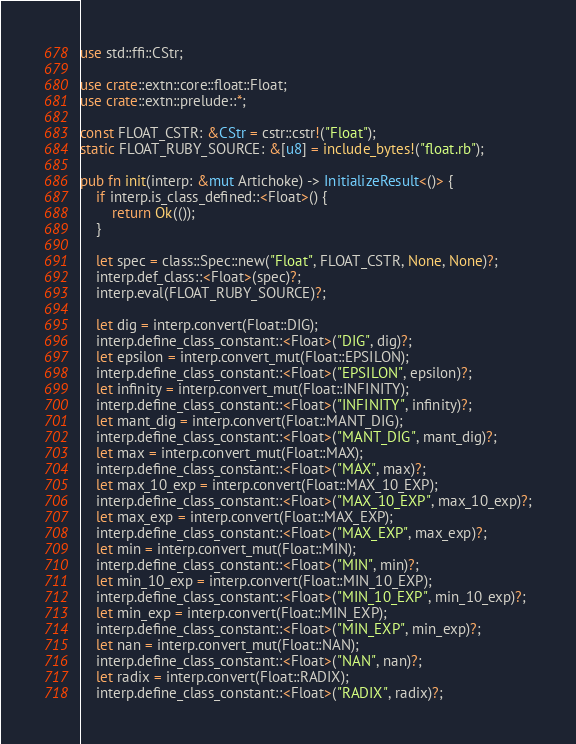<code> <loc_0><loc_0><loc_500><loc_500><_Rust_>use std::ffi::CStr;

use crate::extn::core::float::Float;
use crate::extn::prelude::*;

const FLOAT_CSTR: &CStr = cstr::cstr!("Float");
static FLOAT_RUBY_SOURCE: &[u8] = include_bytes!("float.rb");

pub fn init(interp: &mut Artichoke) -> InitializeResult<()> {
    if interp.is_class_defined::<Float>() {
        return Ok(());
    }

    let spec = class::Spec::new("Float", FLOAT_CSTR, None, None)?;
    interp.def_class::<Float>(spec)?;
    interp.eval(FLOAT_RUBY_SOURCE)?;

    let dig = interp.convert(Float::DIG);
    interp.define_class_constant::<Float>("DIG", dig)?;
    let epsilon = interp.convert_mut(Float::EPSILON);
    interp.define_class_constant::<Float>("EPSILON", epsilon)?;
    let infinity = interp.convert_mut(Float::INFINITY);
    interp.define_class_constant::<Float>("INFINITY", infinity)?;
    let mant_dig = interp.convert(Float::MANT_DIG);
    interp.define_class_constant::<Float>("MANT_DIG", mant_dig)?;
    let max = interp.convert_mut(Float::MAX);
    interp.define_class_constant::<Float>("MAX", max)?;
    let max_10_exp = interp.convert(Float::MAX_10_EXP);
    interp.define_class_constant::<Float>("MAX_10_EXP", max_10_exp)?;
    let max_exp = interp.convert(Float::MAX_EXP);
    interp.define_class_constant::<Float>("MAX_EXP", max_exp)?;
    let min = interp.convert_mut(Float::MIN);
    interp.define_class_constant::<Float>("MIN", min)?;
    let min_10_exp = interp.convert(Float::MIN_10_EXP);
    interp.define_class_constant::<Float>("MIN_10_EXP", min_10_exp)?;
    let min_exp = interp.convert(Float::MIN_EXP);
    interp.define_class_constant::<Float>("MIN_EXP", min_exp)?;
    let nan = interp.convert_mut(Float::NAN);
    interp.define_class_constant::<Float>("NAN", nan)?;
    let radix = interp.convert(Float::RADIX);
    interp.define_class_constant::<Float>("RADIX", radix)?;</code> 